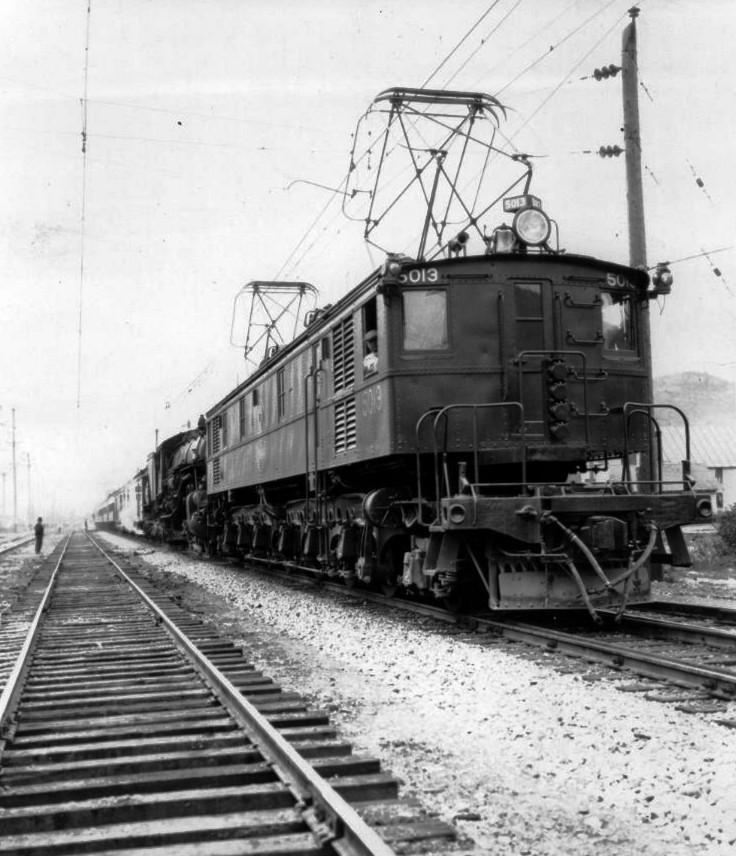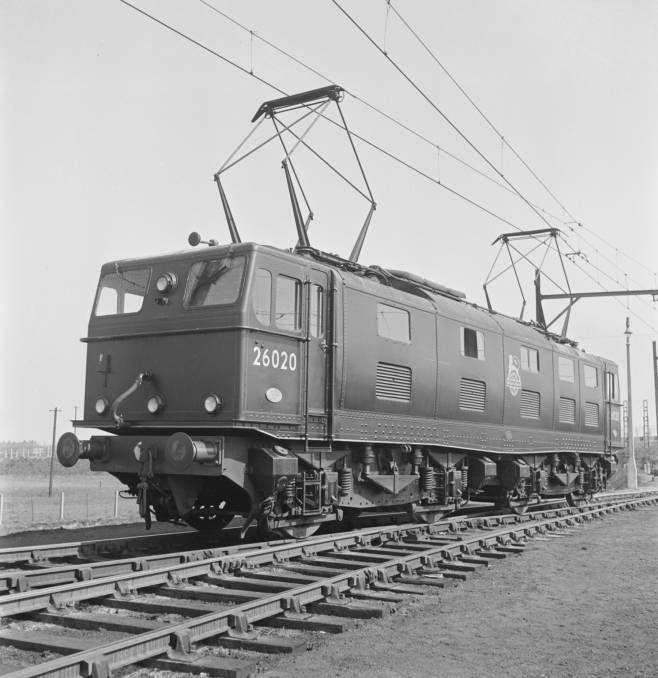The first image is the image on the left, the second image is the image on the right. Evaluate the accuracy of this statement regarding the images: "in the image pair the trains are facing each other". Is it true? Answer yes or no. Yes. The first image is the image on the left, the second image is the image on the right. Given the left and right images, does the statement "The trains in the left and right images head away from each other, in opposite directions." hold true? Answer yes or no. No. 